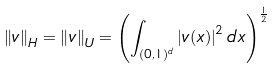Convert formula to latex. <formula><loc_0><loc_0><loc_500><loc_500>\left \| v \right \| _ { H } = \left \| v \right \| _ { U } = \left ( \int _ { ( 0 , 1 ) ^ { d } } \left | v ( x ) \right | ^ { 2 } d x \right ) ^ { \frac { 1 } { 2 } }</formula> 